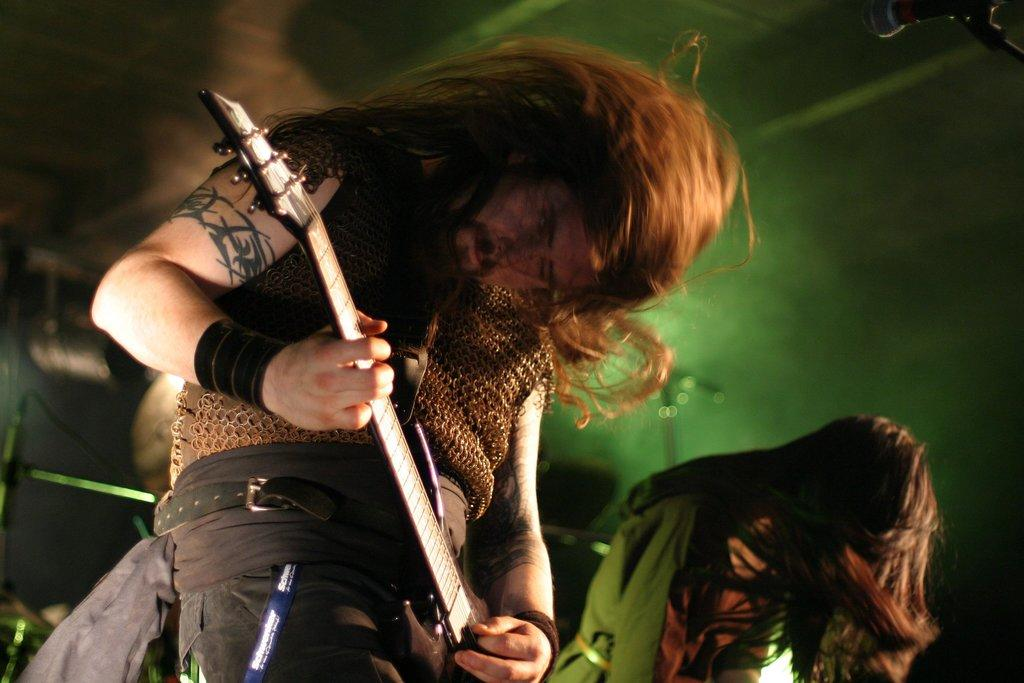How many people are in the image? There are two persons in the image. What is one of the persons doing in the image? One of the persons is playing a musical instrument. What type of pleasure can be seen being derived from the hydrant in the image? There is no hydrant present in the image, so it is not possible to determine any pleasure derived from it. How many dolls are visible in the image? There are no dolls present in the image. 